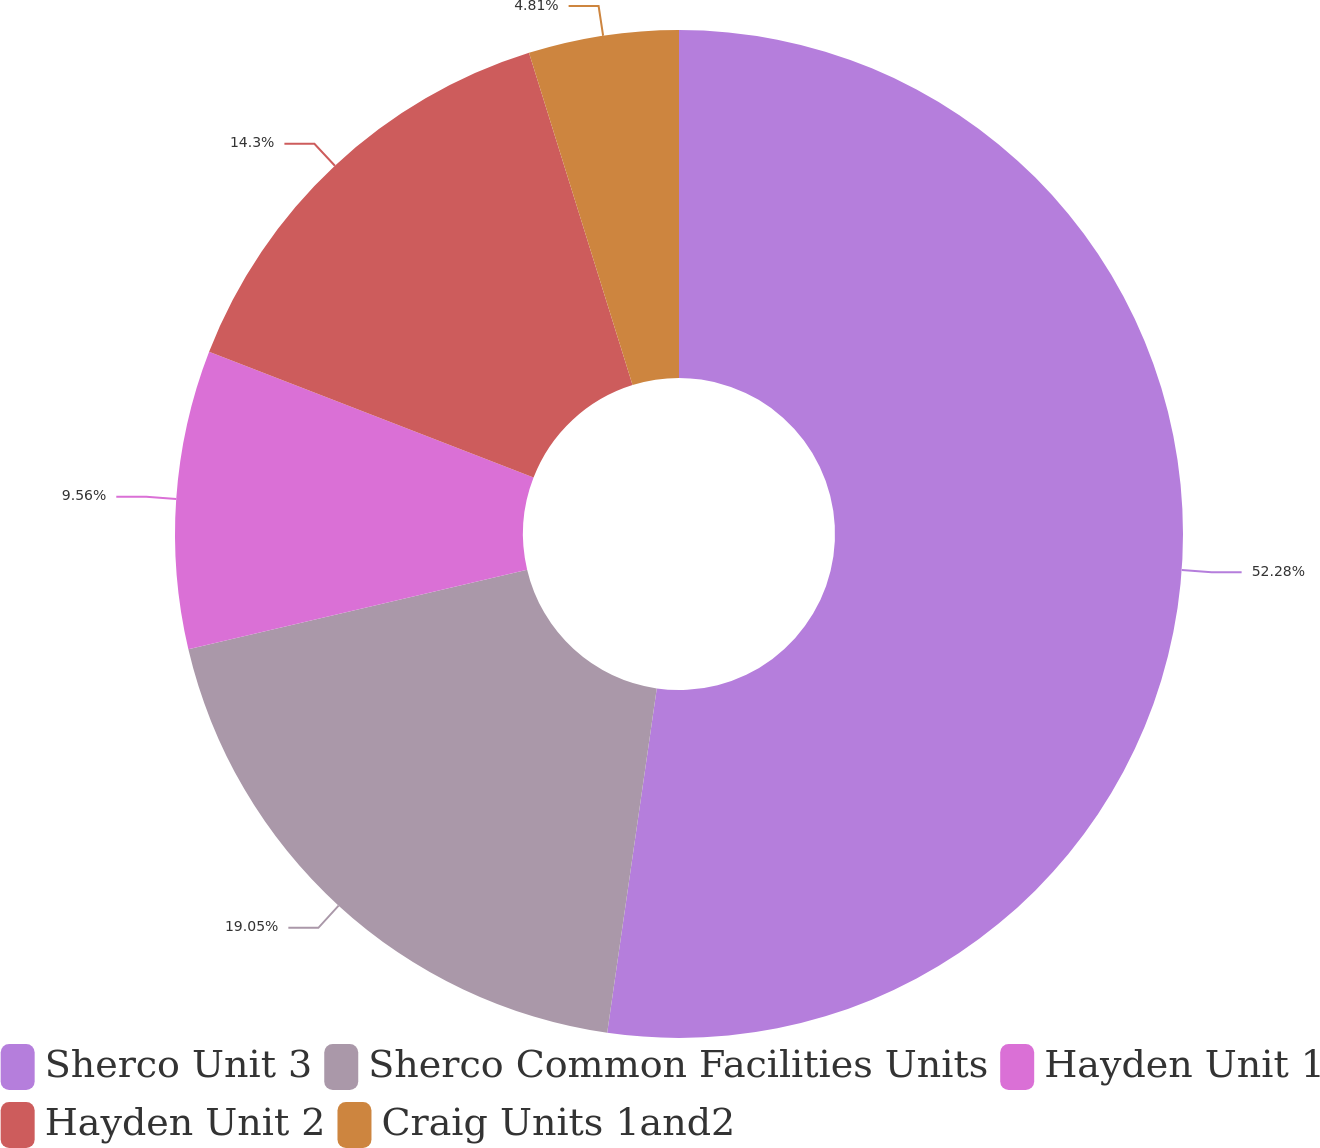Convert chart. <chart><loc_0><loc_0><loc_500><loc_500><pie_chart><fcel>Sherco Unit 3<fcel>Sherco Common Facilities Units<fcel>Hayden Unit 1<fcel>Hayden Unit 2<fcel>Craig Units 1and2<nl><fcel>52.27%<fcel>19.05%<fcel>9.56%<fcel>14.3%<fcel>4.81%<nl></chart> 